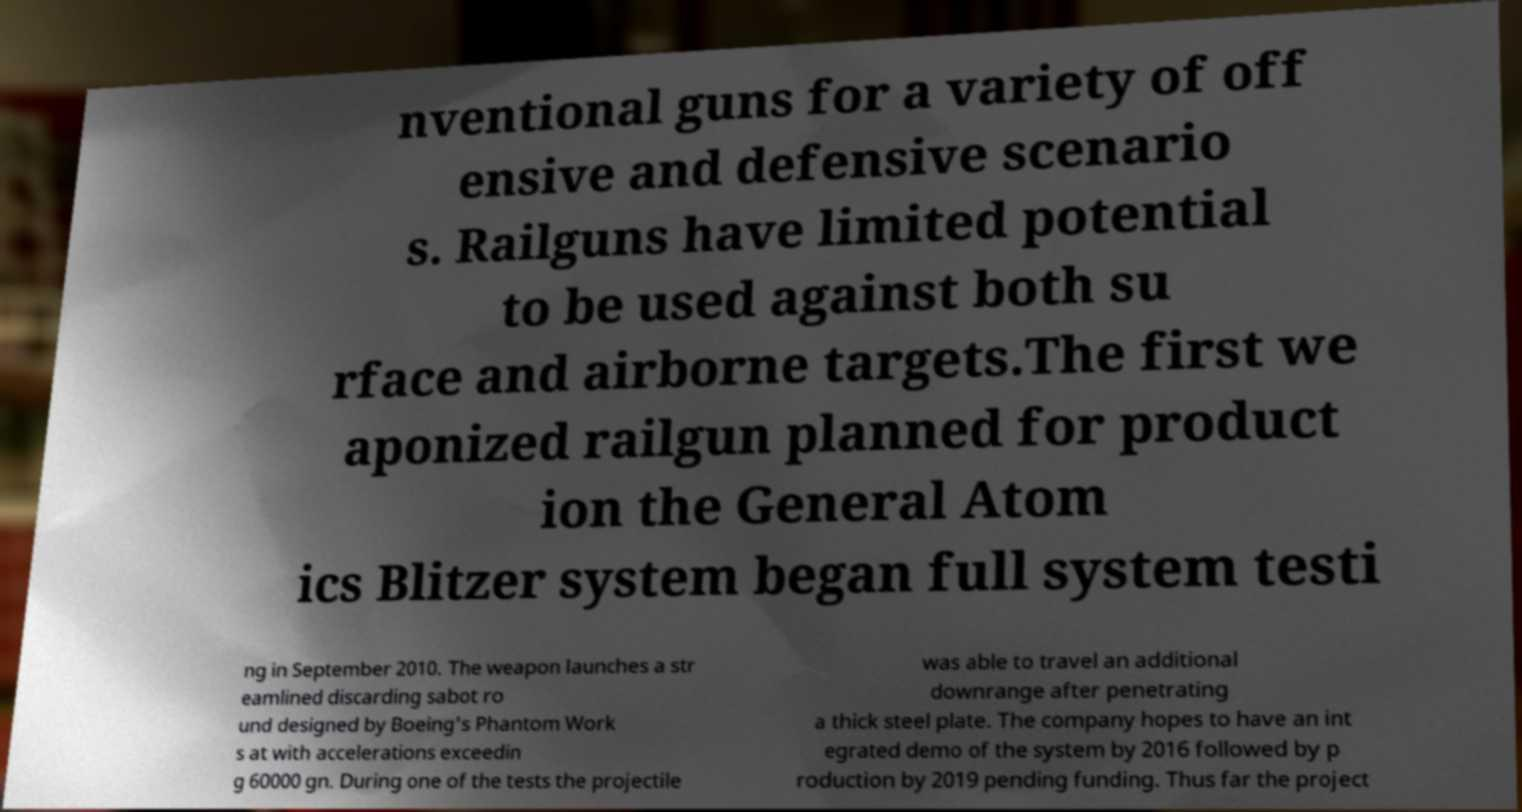Can you accurately transcribe the text from the provided image for me? nventional guns for a variety of off ensive and defensive scenario s. Railguns have limited potential to be used against both su rface and airborne targets.The first we aponized railgun planned for product ion the General Atom ics Blitzer system began full system testi ng in September 2010. The weapon launches a str eamlined discarding sabot ro und designed by Boeing's Phantom Work s at with accelerations exceedin g 60000 gn. During one of the tests the projectile was able to travel an additional downrange after penetrating a thick steel plate. The company hopes to have an int egrated demo of the system by 2016 followed by p roduction by 2019 pending funding. Thus far the project 